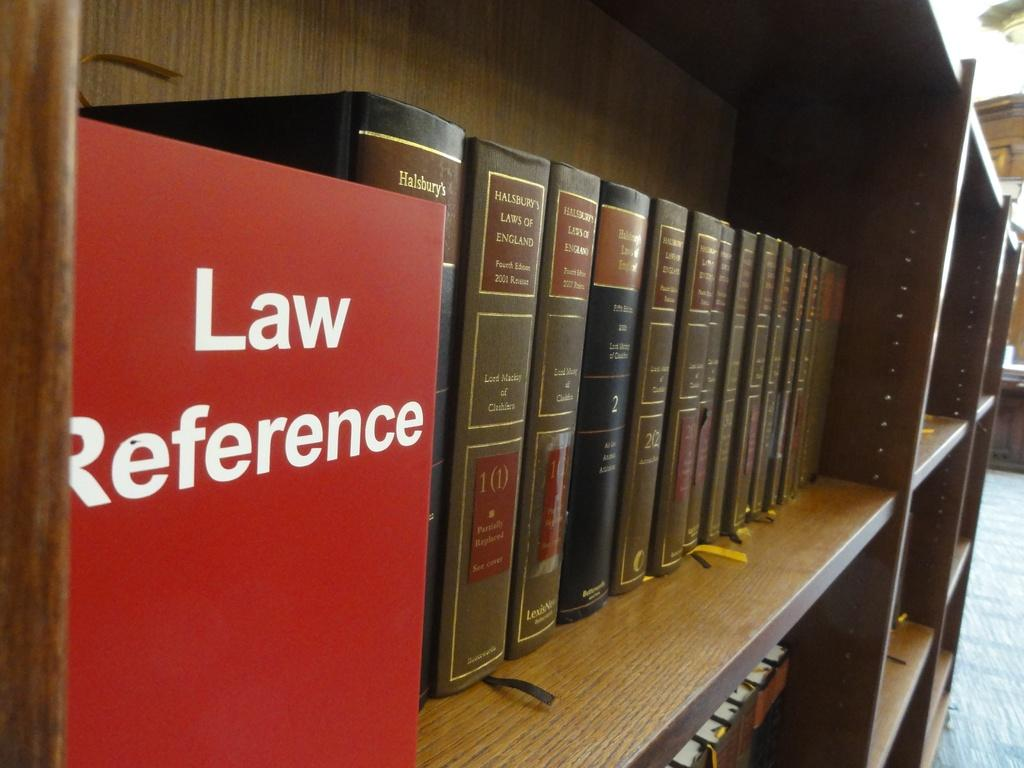<image>
Give a short and clear explanation of the subsequent image. A library bookshelf with Law Reference books along the shelf 